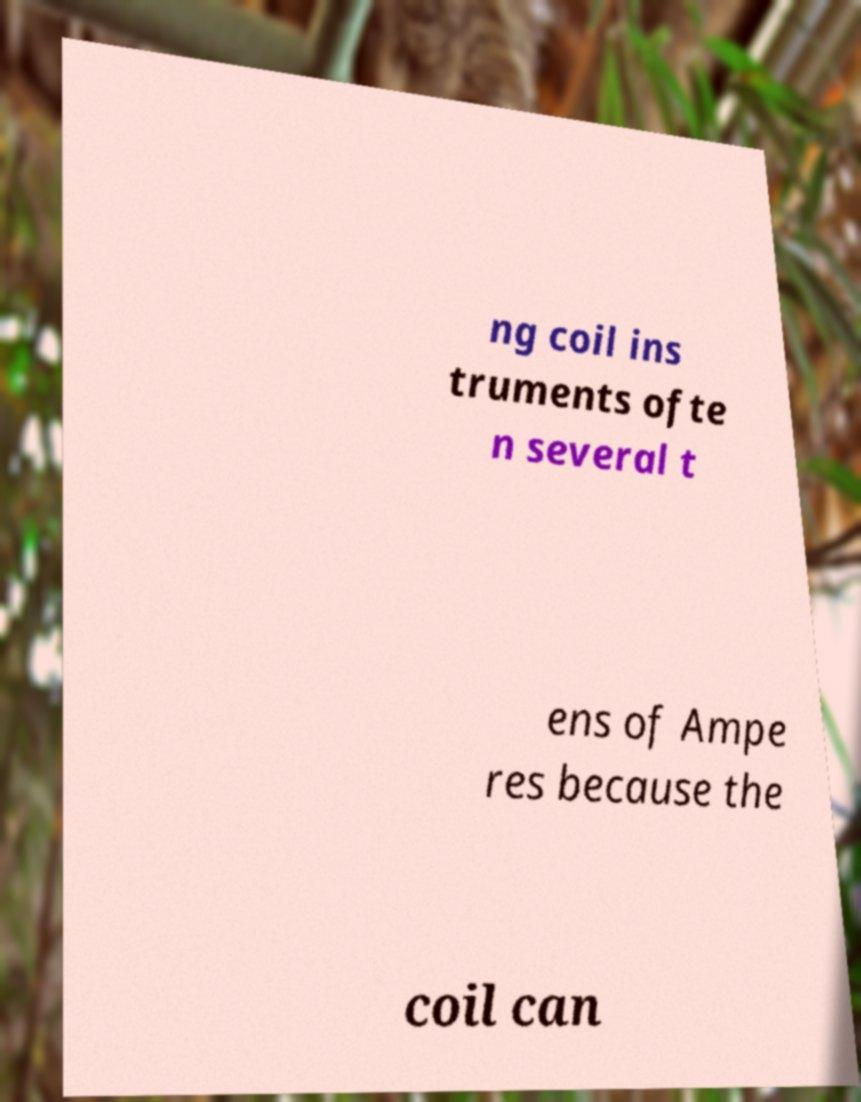Can you accurately transcribe the text from the provided image for me? ng coil ins truments ofte n several t ens of Ampe res because the coil can 